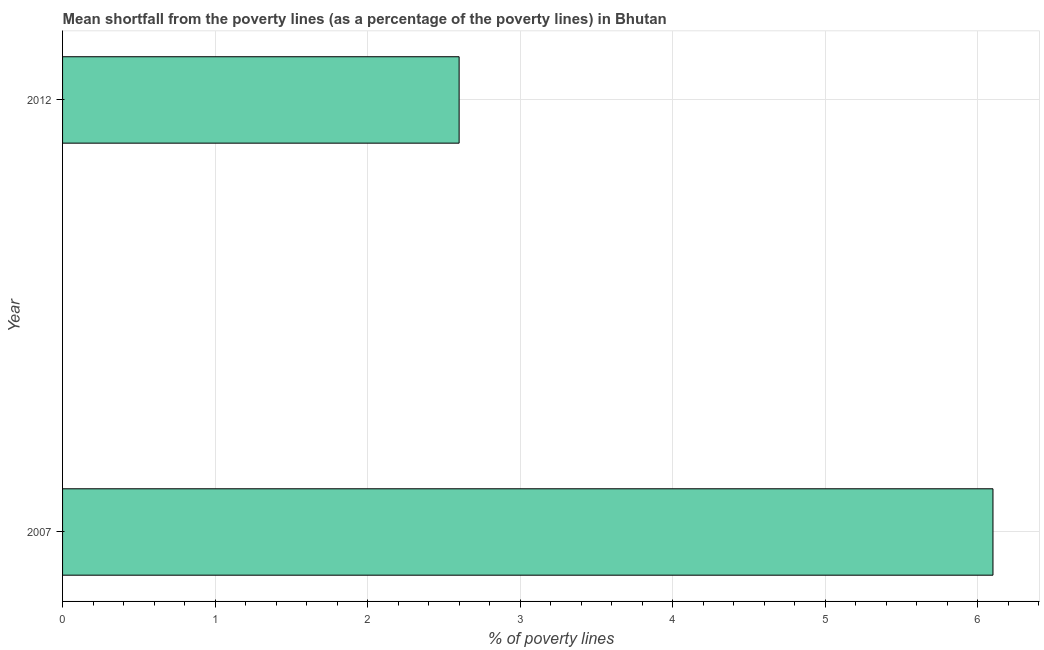Does the graph contain grids?
Your answer should be compact. Yes. What is the title of the graph?
Your answer should be very brief. Mean shortfall from the poverty lines (as a percentage of the poverty lines) in Bhutan. What is the label or title of the X-axis?
Make the answer very short. % of poverty lines. What is the poverty gap at national poverty lines in 2007?
Offer a very short reply. 6.1. Across all years, what is the maximum poverty gap at national poverty lines?
Give a very brief answer. 6.1. Across all years, what is the minimum poverty gap at national poverty lines?
Your answer should be compact. 2.6. In which year was the poverty gap at national poverty lines minimum?
Make the answer very short. 2012. What is the average poverty gap at national poverty lines per year?
Offer a terse response. 4.35. What is the median poverty gap at national poverty lines?
Offer a terse response. 4.35. In how many years, is the poverty gap at national poverty lines greater than 3.6 %?
Give a very brief answer. 1. Do a majority of the years between 2007 and 2012 (inclusive) have poverty gap at national poverty lines greater than 0.2 %?
Give a very brief answer. Yes. What is the ratio of the poverty gap at national poverty lines in 2007 to that in 2012?
Provide a succinct answer. 2.35. How many years are there in the graph?
Ensure brevity in your answer.  2. Are the values on the major ticks of X-axis written in scientific E-notation?
Your response must be concise. No. What is the difference between the % of poverty lines in 2007 and 2012?
Provide a short and direct response. 3.5. What is the ratio of the % of poverty lines in 2007 to that in 2012?
Keep it short and to the point. 2.35. 